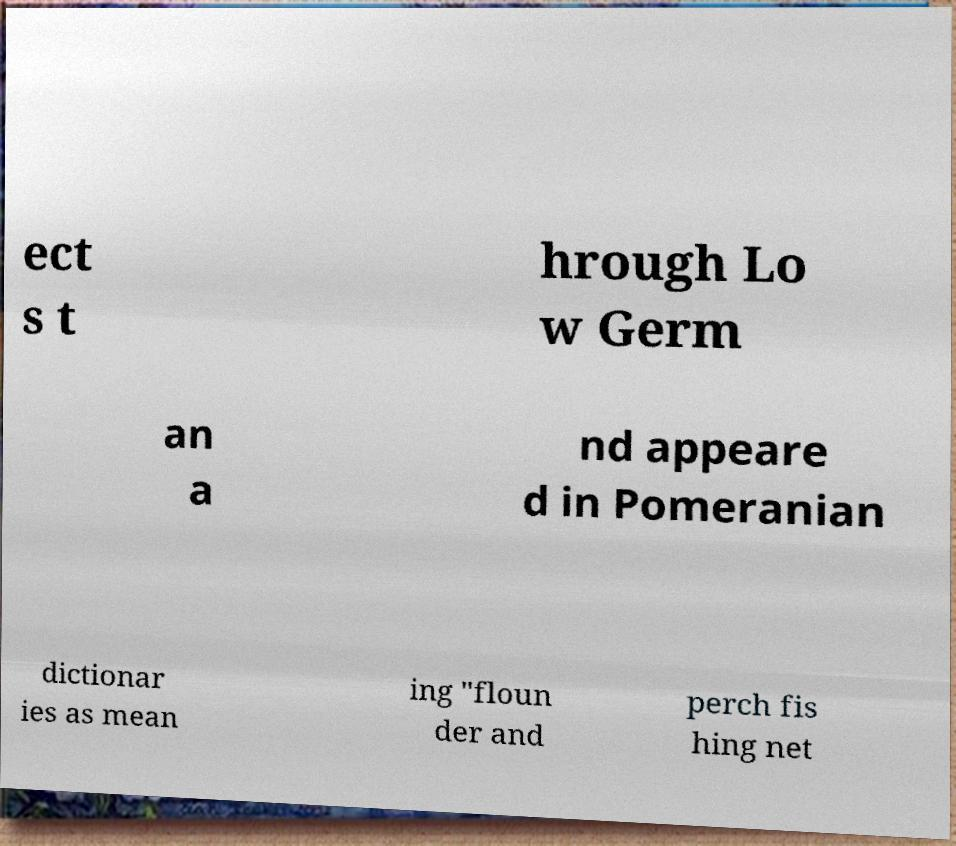For documentation purposes, I need the text within this image transcribed. Could you provide that? ect s t hrough Lo w Germ an a nd appeare d in Pomeranian dictionar ies as mean ing "floun der and perch fis hing net 